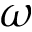Convert formula to latex. <formula><loc_0><loc_0><loc_500><loc_500>\omega</formula> 